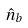Convert formula to latex. <formula><loc_0><loc_0><loc_500><loc_500>\hat { n } _ { b }</formula> 